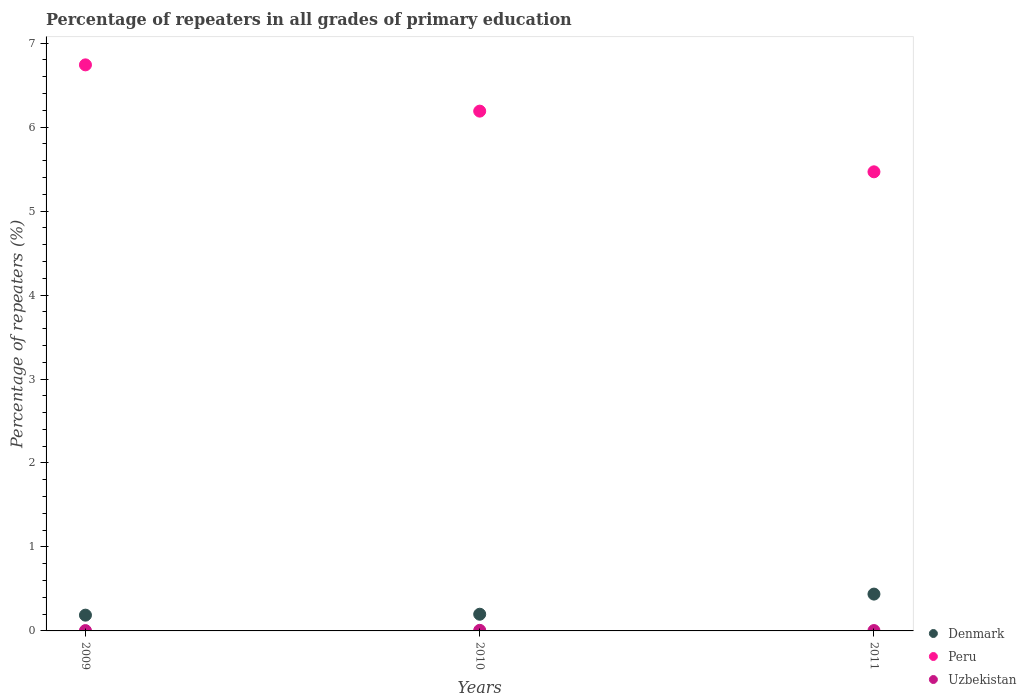How many different coloured dotlines are there?
Your answer should be compact. 3. Is the number of dotlines equal to the number of legend labels?
Your answer should be compact. Yes. What is the percentage of repeaters in Uzbekistan in 2010?
Provide a succinct answer. 0.01. Across all years, what is the maximum percentage of repeaters in Uzbekistan?
Give a very brief answer. 0.01. Across all years, what is the minimum percentage of repeaters in Denmark?
Offer a terse response. 0.19. What is the total percentage of repeaters in Peru in the graph?
Offer a terse response. 18.4. What is the difference between the percentage of repeaters in Denmark in 2010 and that in 2011?
Provide a short and direct response. -0.24. What is the difference between the percentage of repeaters in Peru in 2009 and the percentage of repeaters in Uzbekistan in 2010?
Make the answer very short. 6.73. What is the average percentage of repeaters in Peru per year?
Your answer should be very brief. 6.13. In the year 2009, what is the difference between the percentage of repeaters in Peru and percentage of repeaters in Uzbekistan?
Offer a very short reply. 6.74. What is the ratio of the percentage of repeaters in Uzbekistan in 2009 to that in 2010?
Your answer should be compact. 0.57. Is the percentage of repeaters in Uzbekistan in 2009 less than that in 2011?
Your response must be concise. Yes. Is the difference between the percentage of repeaters in Peru in 2009 and 2010 greater than the difference between the percentage of repeaters in Uzbekistan in 2009 and 2010?
Your answer should be compact. Yes. What is the difference between the highest and the second highest percentage of repeaters in Denmark?
Keep it short and to the point. 0.24. What is the difference between the highest and the lowest percentage of repeaters in Peru?
Provide a short and direct response. 1.27. Is the sum of the percentage of repeaters in Uzbekistan in 2010 and 2011 greater than the maximum percentage of repeaters in Peru across all years?
Give a very brief answer. No. Is the percentage of repeaters in Denmark strictly greater than the percentage of repeaters in Uzbekistan over the years?
Provide a succinct answer. Yes. Is the percentage of repeaters in Peru strictly less than the percentage of repeaters in Denmark over the years?
Make the answer very short. No. How many dotlines are there?
Your response must be concise. 3. How many years are there in the graph?
Give a very brief answer. 3. Are the values on the major ticks of Y-axis written in scientific E-notation?
Give a very brief answer. No. Does the graph contain any zero values?
Your response must be concise. No. Does the graph contain grids?
Keep it short and to the point. No. How are the legend labels stacked?
Provide a short and direct response. Vertical. What is the title of the graph?
Your response must be concise. Percentage of repeaters in all grades of primary education. Does "Italy" appear as one of the legend labels in the graph?
Ensure brevity in your answer.  No. What is the label or title of the Y-axis?
Give a very brief answer. Percentage of repeaters (%). What is the Percentage of repeaters (%) of Denmark in 2009?
Make the answer very short. 0.19. What is the Percentage of repeaters (%) in Peru in 2009?
Your answer should be compact. 6.74. What is the Percentage of repeaters (%) of Uzbekistan in 2009?
Make the answer very short. 0. What is the Percentage of repeaters (%) in Denmark in 2010?
Offer a terse response. 0.2. What is the Percentage of repeaters (%) of Peru in 2010?
Provide a short and direct response. 6.19. What is the Percentage of repeaters (%) of Uzbekistan in 2010?
Keep it short and to the point. 0.01. What is the Percentage of repeaters (%) of Denmark in 2011?
Offer a very short reply. 0.44. What is the Percentage of repeaters (%) in Peru in 2011?
Your answer should be compact. 5.47. What is the Percentage of repeaters (%) in Uzbekistan in 2011?
Your answer should be compact. 0. Across all years, what is the maximum Percentage of repeaters (%) of Denmark?
Your response must be concise. 0.44. Across all years, what is the maximum Percentage of repeaters (%) of Peru?
Ensure brevity in your answer.  6.74. Across all years, what is the maximum Percentage of repeaters (%) in Uzbekistan?
Offer a terse response. 0.01. Across all years, what is the minimum Percentage of repeaters (%) of Denmark?
Ensure brevity in your answer.  0.19. Across all years, what is the minimum Percentage of repeaters (%) of Peru?
Make the answer very short. 5.47. Across all years, what is the minimum Percentage of repeaters (%) of Uzbekistan?
Give a very brief answer. 0. What is the total Percentage of repeaters (%) of Denmark in the graph?
Your response must be concise. 0.83. What is the total Percentage of repeaters (%) in Peru in the graph?
Make the answer very short. 18.4. What is the total Percentage of repeaters (%) in Uzbekistan in the graph?
Provide a short and direct response. 0.02. What is the difference between the Percentage of repeaters (%) in Denmark in 2009 and that in 2010?
Provide a short and direct response. -0.01. What is the difference between the Percentage of repeaters (%) in Peru in 2009 and that in 2010?
Your answer should be very brief. 0.55. What is the difference between the Percentage of repeaters (%) in Uzbekistan in 2009 and that in 2010?
Provide a succinct answer. -0. What is the difference between the Percentage of repeaters (%) of Denmark in 2009 and that in 2011?
Make the answer very short. -0.25. What is the difference between the Percentage of repeaters (%) in Peru in 2009 and that in 2011?
Offer a very short reply. 1.27. What is the difference between the Percentage of repeaters (%) in Uzbekistan in 2009 and that in 2011?
Your answer should be compact. -0. What is the difference between the Percentage of repeaters (%) of Denmark in 2010 and that in 2011?
Your answer should be very brief. -0.24. What is the difference between the Percentage of repeaters (%) of Peru in 2010 and that in 2011?
Offer a very short reply. 0.72. What is the difference between the Percentage of repeaters (%) in Uzbekistan in 2010 and that in 2011?
Keep it short and to the point. 0. What is the difference between the Percentage of repeaters (%) of Denmark in 2009 and the Percentage of repeaters (%) of Peru in 2010?
Ensure brevity in your answer.  -6. What is the difference between the Percentage of repeaters (%) in Denmark in 2009 and the Percentage of repeaters (%) in Uzbekistan in 2010?
Your response must be concise. 0.18. What is the difference between the Percentage of repeaters (%) of Peru in 2009 and the Percentage of repeaters (%) of Uzbekistan in 2010?
Ensure brevity in your answer.  6.73. What is the difference between the Percentage of repeaters (%) of Denmark in 2009 and the Percentage of repeaters (%) of Peru in 2011?
Ensure brevity in your answer.  -5.28. What is the difference between the Percentage of repeaters (%) of Denmark in 2009 and the Percentage of repeaters (%) of Uzbekistan in 2011?
Offer a very short reply. 0.18. What is the difference between the Percentage of repeaters (%) in Peru in 2009 and the Percentage of repeaters (%) in Uzbekistan in 2011?
Ensure brevity in your answer.  6.74. What is the difference between the Percentage of repeaters (%) in Denmark in 2010 and the Percentage of repeaters (%) in Peru in 2011?
Ensure brevity in your answer.  -5.27. What is the difference between the Percentage of repeaters (%) in Denmark in 2010 and the Percentage of repeaters (%) in Uzbekistan in 2011?
Your answer should be very brief. 0.19. What is the difference between the Percentage of repeaters (%) of Peru in 2010 and the Percentage of repeaters (%) of Uzbekistan in 2011?
Keep it short and to the point. 6.19. What is the average Percentage of repeaters (%) of Denmark per year?
Ensure brevity in your answer.  0.28. What is the average Percentage of repeaters (%) in Peru per year?
Keep it short and to the point. 6.13. What is the average Percentage of repeaters (%) of Uzbekistan per year?
Make the answer very short. 0.01. In the year 2009, what is the difference between the Percentage of repeaters (%) in Denmark and Percentage of repeaters (%) in Peru?
Offer a terse response. -6.55. In the year 2009, what is the difference between the Percentage of repeaters (%) of Denmark and Percentage of repeaters (%) of Uzbekistan?
Make the answer very short. 0.18. In the year 2009, what is the difference between the Percentage of repeaters (%) in Peru and Percentage of repeaters (%) in Uzbekistan?
Offer a terse response. 6.74. In the year 2010, what is the difference between the Percentage of repeaters (%) of Denmark and Percentage of repeaters (%) of Peru?
Your answer should be very brief. -5.99. In the year 2010, what is the difference between the Percentage of repeaters (%) in Denmark and Percentage of repeaters (%) in Uzbekistan?
Give a very brief answer. 0.19. In the year 2010, what is the difference between the Percentage of repeaters (%) in Peru and Percentage of repeaters (%) in Uzbekistan?
Keep it short and to the point. 6.18. In the year 2011, what is the difference between the Percentage of repeaters (%) of Denmark and Percentage of repeaters (%) of Peru?
Offer a terse response. -5.03. In the year 2011, what is the difference between the Percentage of repeaters (%) in Denmark and Percentage of repeaters (%) in Uzbekistan?
Make the answer very short. 0.43. In the year 2011, what is the difference between the Percentage of repeaters (%) in Peru and Percentage of repeaters (%) in Uzbekistan?
Ensure brevity in your answer.  5.46. What is the ratio of the Percentage of repeaters (%) in Denmark in 2009 to that in 2010?
Your answer should be compact. 0.94. What is the ratio of the Percentage of repeaters (%) of Peru in 2009 to that in 2010?
Provide a succinct answer. 1.09. What is the ratio of the Percentage of repeaters (%) in Uzbekistan in 2009 to that in 2010?
Make the answer very short. 0.57. What is the ratio of the Percentage of repeaters (%) of Denmark in 2009 to that in 2011?
Your answer should be compact. 0.43. What is the ratio of the Percentage of repeaters (%) of Peru in 2009 to that in 2011?
Ensure brevity in your answer.  1.23. What is the ratio of the Percentage of repeaters (%) in Uzbekistan in 2009 to that in 2011?
Ensure brevity in your answer.  0.92. What is the ratio of the Percentage of repeaters (%) in Denmark in 2010 to that in 2011?
Your answer should be very brief. 0.45. What is the ratio of the Percentage of repeaters (%) in Peru in 2010 to that in 2011?
Ensure brevity in your answer.  1.13. What is the ratio of the Percentage of repeaters (%) of Uzbekistan in 2010 to that in 2011?
Your answer should be very brief. 1.62. What is the difference between the highest and the second highest Percentage of repeaters (%) in Denmark?
Ensure brevity in your answer.  0.24. What is the difference between the highest and the second highest Percentage of repeaters (%) in Peru?
Provide a short and direct response. 0.55. What is the difference between the highest and the second highest Percentage of repeaters (%) in Uzbekistan?
Keep it short and to the point. 0. What is the difference between the highest and the lowest Percentage of repeaters (%) in Denmark?
Make the answer very short. 0.25. What is the difference between the highest and the lowest Percentage of repeaters (%) in Peru?
Make the answer very short. 1.27. What is the difference between the highest and the lowest Percentage of repeaters (%) of Uzbekistan?
Make the answer very short. 0. 